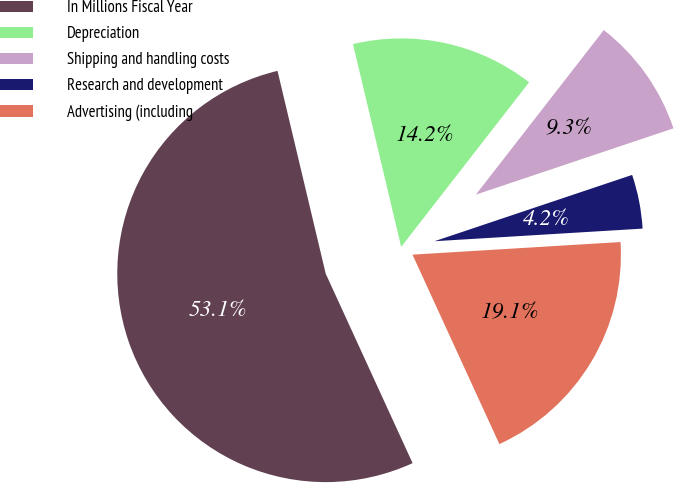Convert chart. <chart><loc_0><loc_0><loc_500><loc_500><pie_chart><fcel>In Millions Fiscal Year<fcel>Depreciation<fcel>Shipping and handling costs<fcel>Research and development<fcel>Advertising (including<nl><fcel>53.13%<fcel>14.23%<fcel>9.33%<fcel>4.19%<fcel>19.12%<nl></chart> 